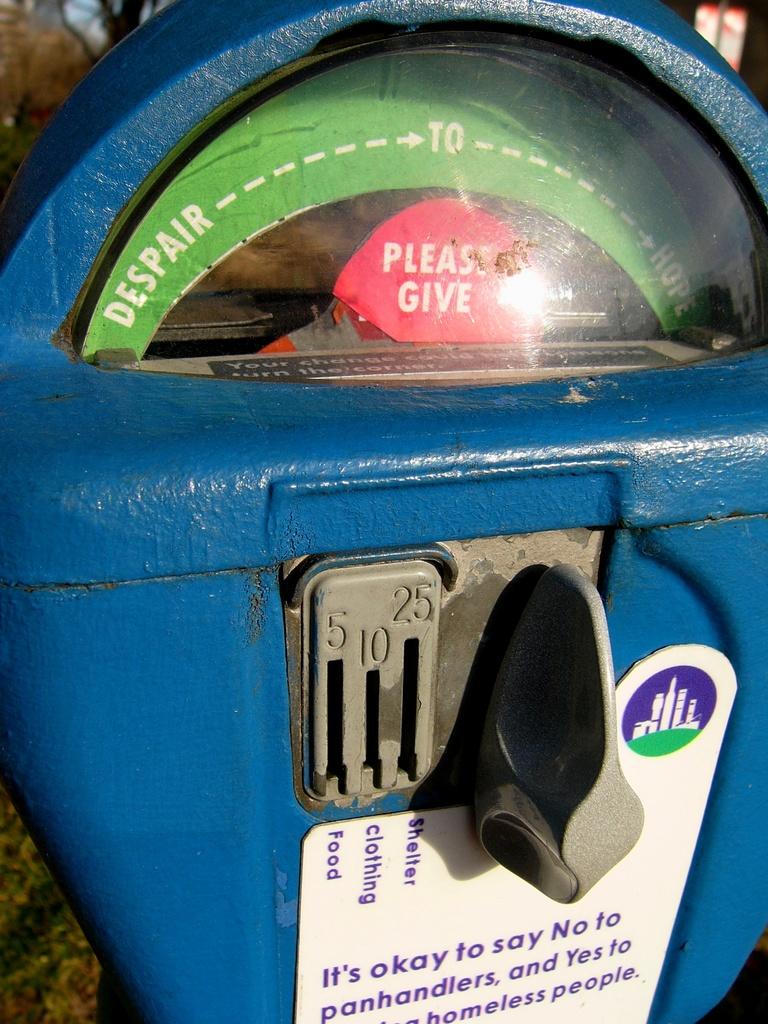Does this meter send proceeds to the homeless?
Provide a succinct answer. Yes. 